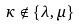<formula> <loc_0><loc_0><loc_500><loc_500>\kappa \notin \{ \lambda , \mu \}</formula> 